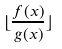<formula> <loc_0><loc_0><loc_500><loc_500>\lfloor \frac { f ( x ) } { g ( x ) } \rfloor</formula> 